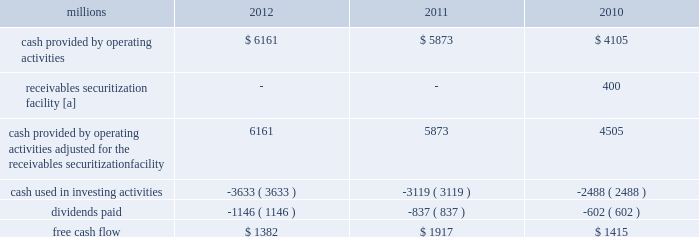F0b7 free cash flow 2013 cash generated by operating activities totaled $ 6.2 billion , reduced by $ 3.6 billion for cash used in investing activities and a 37% ( 37 % ) increase in dividends paid , yielding free cash flow of $ 1.4 billion .
Free cash flow is defined as cash provided by operating activities ( adjusted for the reclassification of our receivables securitization facility ) , less cash used in investing activities and dividends paid .
Free cash flow is not considered a financial measure under accounting principles generally accepted in the u.s .
( gaap ) by sec regulation g and item 10 of sec regulation s-k and may not be defined and calculated by other companies in the same manner .
We believe free cash flow is important to management and investors in evaluating our financial performance and measures our ability to generate cash without additional external financings .
Free cash flow should be considered in addition to , rather than as a substitute for , cash provided by operating activities .
The table reconciles cash provided by operating activities ( gaap measure ) to free cash flow ( non-gaap measure ) : millions 2012 2011 2010 .
[a] effective january 1 , 2010 , a new accounting standard required us to account for receivables transferred under our receivables securitization facility as secured borrowings in our consolidated statements of financial position and as financing activities in our consolidated statements of cash flows .
The receivables securitization facility is included in our free cash flow calculation to adjust cash provided by operating activities as though our receivables securitization facility had been accounted for under the new accounting standard for all periods presented .
2013 outlook f0b7 safety 2013 operating a safe railroad benefits our employees , our customers , our shareholders , and the communities we serve .
We will continue using a multi-faceted approach to safety , utilizing technology , risk assessment , quality control , training and employee engagement , and targeted capital investments .
We will continue using and expanding the deployment of total safety culture throughout our operations , which allows us to identify and implement best practices for employee and operational safety .
Derailment prevention and the reduction of grade crossing incidents are critical aspects of our safety programs .
We will continue our efforts to increase rail defect detection ; improve or close crossings ; and educate the public and law enforcement agencies about crossing safety through a combination of our own programs ( including risk assessment strategies ) , various industry programs and local community activities across our network .
F0b7 network operations 2013 we will continue focusing on our six critical initiatives to improve safety , service and productivity during 2013 .
We are seeing solid contributions from reducing variability , continuous improvements , and standard work .
Resource agility allows us to respond quickly to changing market conditions and network disruptions from weather or other events .
The railroad continues to benefit from capital investments that allow us to build capacity for growth and harden our infrastructure to reduce failure .
F0b7 fuel prices 2013 uncertainty about the economy makes projections of fuel prices difficult .
We again could see volatile fuel prices during the year , as they are sensitive to global and u.s .
Domestic demand , refining capacity , geopolitical events , weather conditions and other factors .
To reduce the impact of fuel price on earnings , we will continue seeking cost recovery from our customers through our fuel surcharge programs and expanding our fuel conservation efforts .
F0b7 capital plan 2013 in 2013 , we plan to make total capital investments of approximately $ 3.6 billion , including expenditures for positive train control ( ptc ) , which may be revised if business conditions warrant or if new laws or regulations affect our ability to generate sufficient returns on these investments .
( see further discussion in this item 7 under liquidity and capital resources 2013 capital plan. ) .
For the planned 2013 capital investments , what percentage are these of actual 2012 free cash flow? 
Computations: ((3.6 * 1000) / 1382)
Answer: 2.60492. F0b7 free cash flow 2013 cash generated by operating activities totaled $ 6.2 billion , reduced by $ 3.6 billion for cash used in investing activities and a 37% ( 37 % ) increase in dividends paid , yielding free cash flow of $ 1.4 billion .
Free cash flow is defined as cash provided by operating activities ( adjusted for the reclassification of our receivables securitization facility ) , less cash used in investing activities and dividends paid .
Free cash flow is not considered a financial measure under accounting principles generally accepted in the u.s .
( gaap ) by sec regulation g and item 10 of sec regulation s-k and may not be defined and calculated by other companies in the same manner .
We believe free cash flow is important to management and investors in evaluating our financial performance and measures our ability to generate cash without additional external financings .
Free cash flow should be considered in addition to , rather than as a substitute for , cash provided by operating activities .
The table reconciles cash provided by operating activities ( gaap measure ) to free cash flow ( non-gaap measure ) : millions 2012 2011 2010 .
[a] effective january 1 , 2010 , a new accounting standard required us to account for receivables transferred under our receivables securitization facility as secured borrowings in our consolidated statements of financial position and as financing activities in our consolidated statements of cash flows .
The receivables securitization facility is included in our free cash flow calculation to adjust cash provided by operating activities as though our receivables securitization facility had been accounted for under the new accounting standard for all periods presented .
2013 outlook f0b7 safety 2013 operating a safe railroad benefits our employees , our customers , our shareholders , and the communities we serve .
We will continue using a multi-faceted approach to safety , utilizing technology , risk assessment , quality control , training and employee engagement , and targeted capital investments .
We will continue using and expanding the deployment of total safety culture throughout our operations , which allows us to identify and implement best practices for employee and operational safety .
Derailment prevention and the reduction of grade crossing incidents are critical aspects of our safety programs .
We will continue our efforts to increase rail defect detection ; improve or close crossings ; and educate the public and law enforcement agencies about crossing safety through a combination of our own programs ( including risk assessment strategies ) , various industry programs and local community activities across our network .
F0b7 network operations 2013 we will continue focusing on our six critical initiatives to improve safety , service and productivity during 2013 .
We are seeing solid contributions from reducing variability , continuous improvements , and standard work .
Resource agility allows us to respond quickly to changing market conditions and network disruptions from weather or other events .
The railroad continues to benefit from capital investments that allow us to build capacity for growth and harden our infrastructure to reduce failure .
F0b7 fuel prices 2013 uncertainty about the economy makes projections of fuel prices difficult .
We again could see volatile fuel prices during the year , as they are sensitive to global and u.s .
Domestic demand , refining capacity , geopolitical events , weather conditions and other factors .
To reduce the impact of fuel price on earnings , we will continue seeking cost recovery from our customers through our fuel surcharge programs and expanding our fuel conservation efforts .
F0b7 capital plan 2013 in 2013 , we plan to make total capital investments of approximately $ 3.6 billion , including expenditures for positive train control ( ptc ) , which may be revised if business conditions warrant or if new laws or regulations affect our ability to generate sufficient returns on these investments .
( see further discussion in this item 7 under liquidity and capital resources 2013 capital plan. ) .
What was the change in free cash flow from 2010 to 2011 , in millions? 
Computations: (1917 - 1415)
Answer: 502.0. 